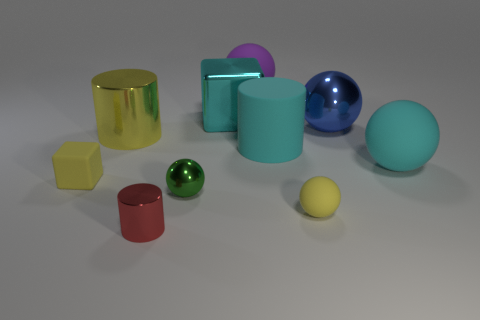Subtract all big cyan spheres. How many spheres are left? 4 Subtract all blue balls. How many balls are left? 4 Subtract all brown balls. Subtract all brown cylinders. How many balls are left? 5 Subtract all cubes. How many objects are left? 8 Add 7 tiny yellow rubber spheres. How many tiny yellow rubber spheres are left? 8 Add 3 big yellow cylinders. How many big yellow cylinders exist? 4 Subtract 0 brown cylinders. How many objects are left? 10 Subtract all shiny cylinders. Subtract all small yellow rubber spheres. How many objects are left? 7 